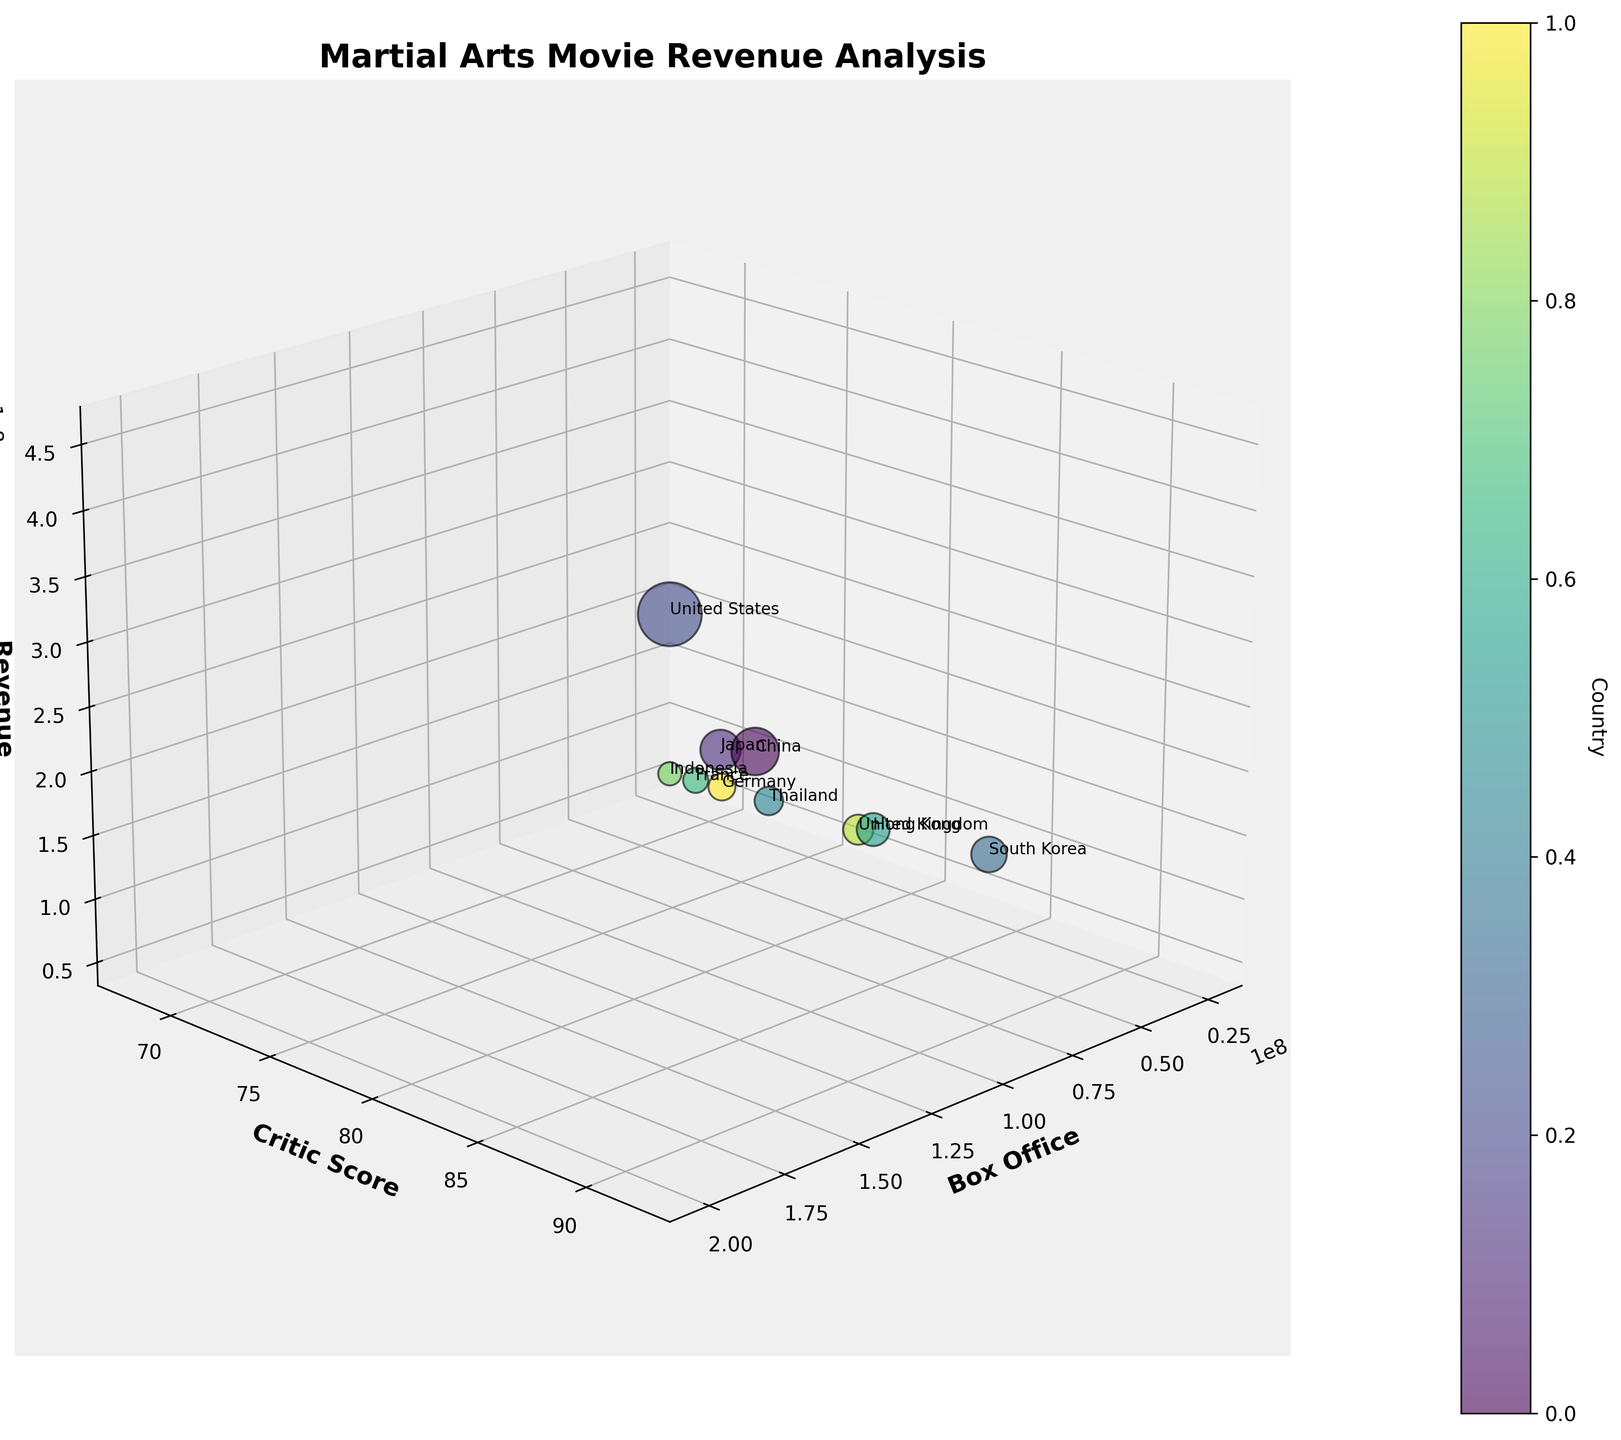What's the title of the figure? The title is the text prominently displayed at the top of the chart, usually in a larger font size and bold formatting. Look at the top of the figure to find the title.
Answer: Martial Arts Movie Revenue Analysis How many countries are represented in the plot? Each bubble in the chart represents a country, and the number of bubbles indicates the number of countries. Count the bubbles.
Answer: 10 Which country has the highest box office earnings? The box office earnings are depicted on the x-axis. Locate the bubble farthest to the right to identify the country with the highest earnings.
Answer: United States Which country has the lowest critic score? The critic scores are shown on the y-axis. Identify the bubble positioned lowest on the y-axis to find the country with the lowest score.
Answer: Indonesia Which country has both a high box office and a high critc score? Look for a bubble that is positioned high on the y-axis (indicating a high critic score) and far to the right on the x-axis (indicating a high box office).
Answer: United States What is the average revenue of the movies from China, Japan, and Hong Kong? Look at the z-axis values for China, Japan, and Hong Kong, sum them up and then divide by 3 to find the average. The revenues are 250,000,000 (China), 180,000,000 (Japan), and 120,000,000 (Hong Kong). Sum: 250,000,000 + 180,000,000 + 120,000,000 = 550,000,000. Average: 550,000,000 / 3 = 183,333,333.33
Answer: 183,333,333.33 Compare the revenue of South Korea and Germany. Which one is higher? Find the z-axis values for South Korea and Germany and compare them. South Korea has a revenue of 140,000,000, and Germany has a revenue of 80,000,000.
Answer: South Korea How does Thailand's critic score compare to France's? Look at the y-axis values for Thailand and France. Thailand has a critic score of 75, and France has a critic score of 70.
Answer: Thailand is higher What is the approximate size of the bubble for the United States? The size of a bubble is determined by the revenue (z-axis) relative to the maximum revenue in the dataset. The largest revenue is 450,000,000 (United States), hence its bubble size is the largest in the plot.
Answer: Largest What is the color associated with Germany on the plot? Colors are assigned to different countries using a colormap. Identify the specific color of the bubble corresponding to Germany to answer this question.
Answer: Specific color in colormap 